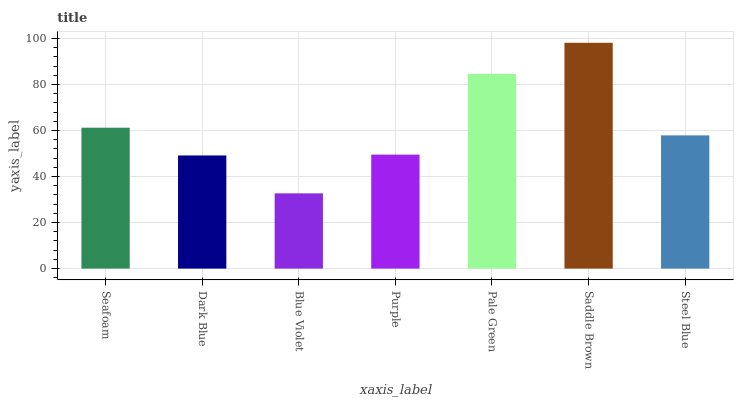Is Blue Violet the minimum?
Answer yes or no. Yes. Is Saddle Brown the maximum?
Answer yes or no. Yes. Is Dark Blue the minimum?
Answer yes or no. No. Is Dark Blue the maximum?
Answer yes or no. No. Is Seafoam greater than Dark Blue?
Answer yes or no. Yes. Is Dark Blue less than Seafoam?
Answer yes or no. Yes. Is Dark Blue greater than Seafoam?
Answer yes or no. No. Is Seafoam less than Dark Blue?
Answer yes or no. No. Is Steel Blue the high median?
Answer yes or no. Yes. Is Steel Blue the low median?
Answer yes or no. Yes. Is Blue Violet the high median?
Answer yes or no. No. Is Saddle Brown the low median?
Answer yes or no. No. 